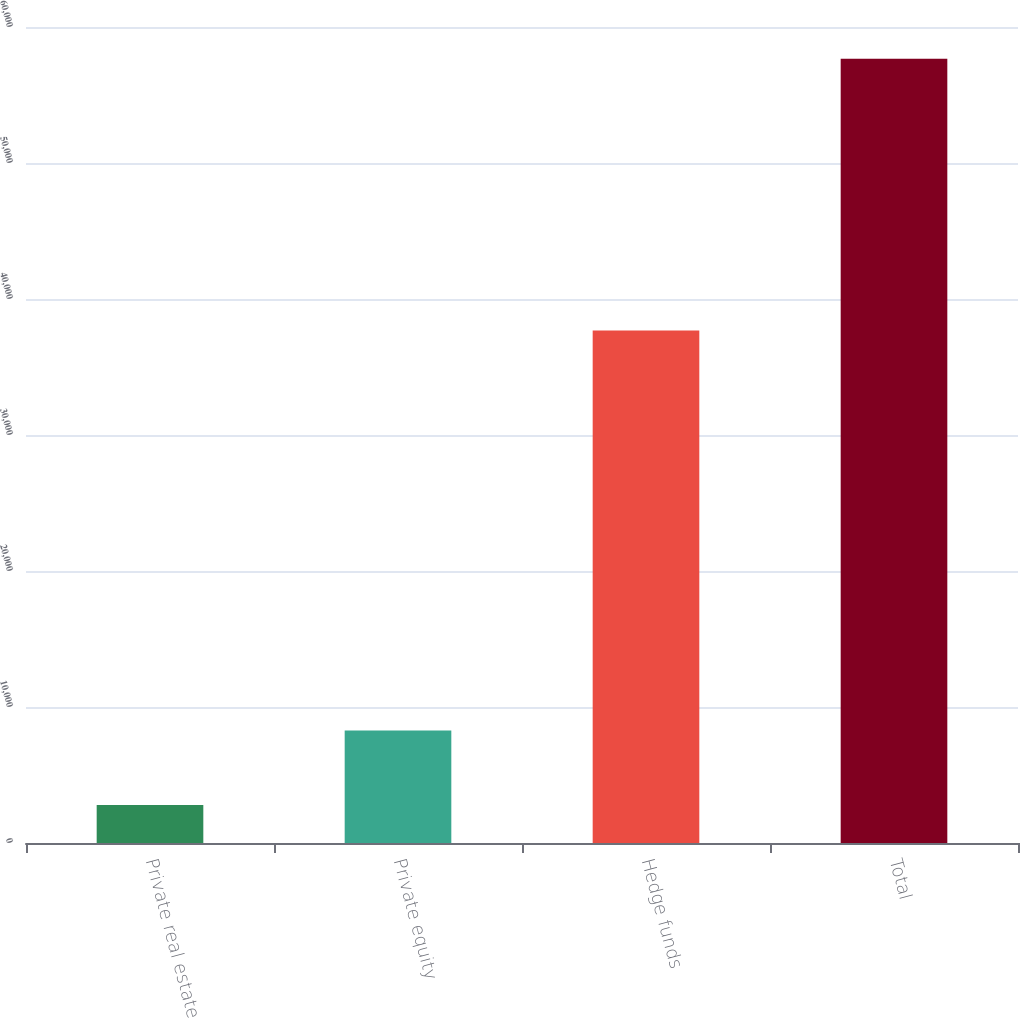<chart> <loc_0><loc_0><loc_500><loc_500><bar_chart><fcel>Private real estate<fcel>Private equity<fcel>Hedge funds<fcel>Total<nl><fcel>2787<fcel>8275.7<fcel>37688<fcel>57674<nl></chart> 